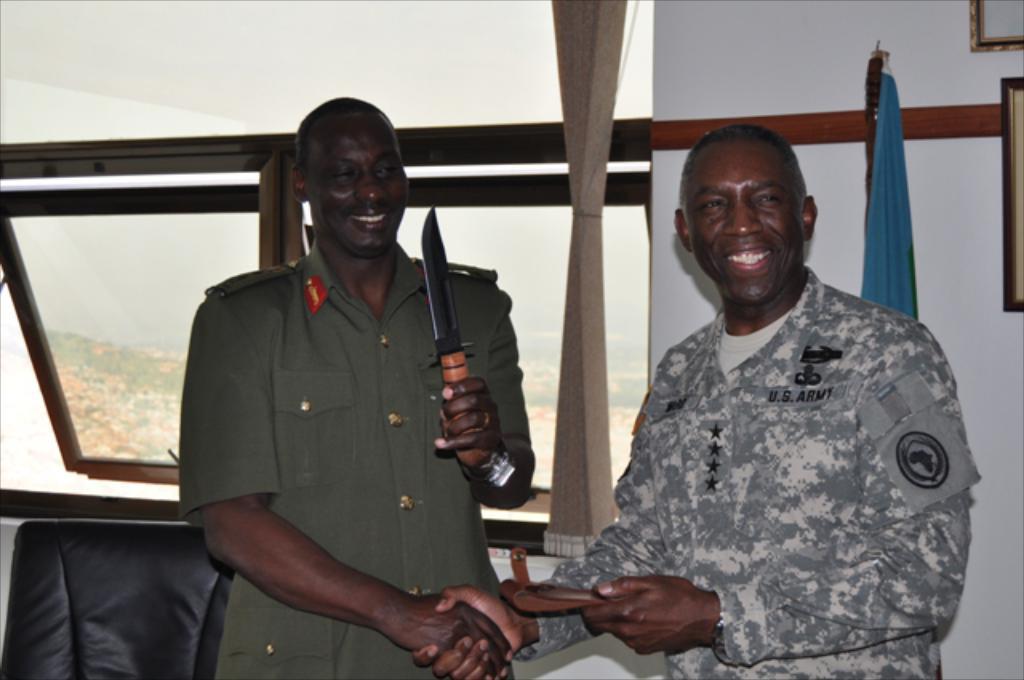How would you summarize this image in a sentence or two? The man in green uniform is holding a knife in his hand. He is shaking his hand with the man standing beside him. Both of them are smiling. Behind them, we see a sofa, curtain and a glass window from which we can see trees. Beside that, we see a white wall on which photo frames are placed. 